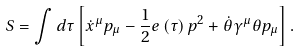Convert formula to latex. <formula><loc_0><loc_0><loc_500><loc_500>S = \int d \tau \left [ \dot { x } ^ { \mu } p _ { \mu } - \frac { 1 } { 2 } e \left ( \tau \right ) p ^ { 2 } + \dot { \theta } \gamma ^ { \mu } \theta p _ { \mu } \right ] .</formula> 